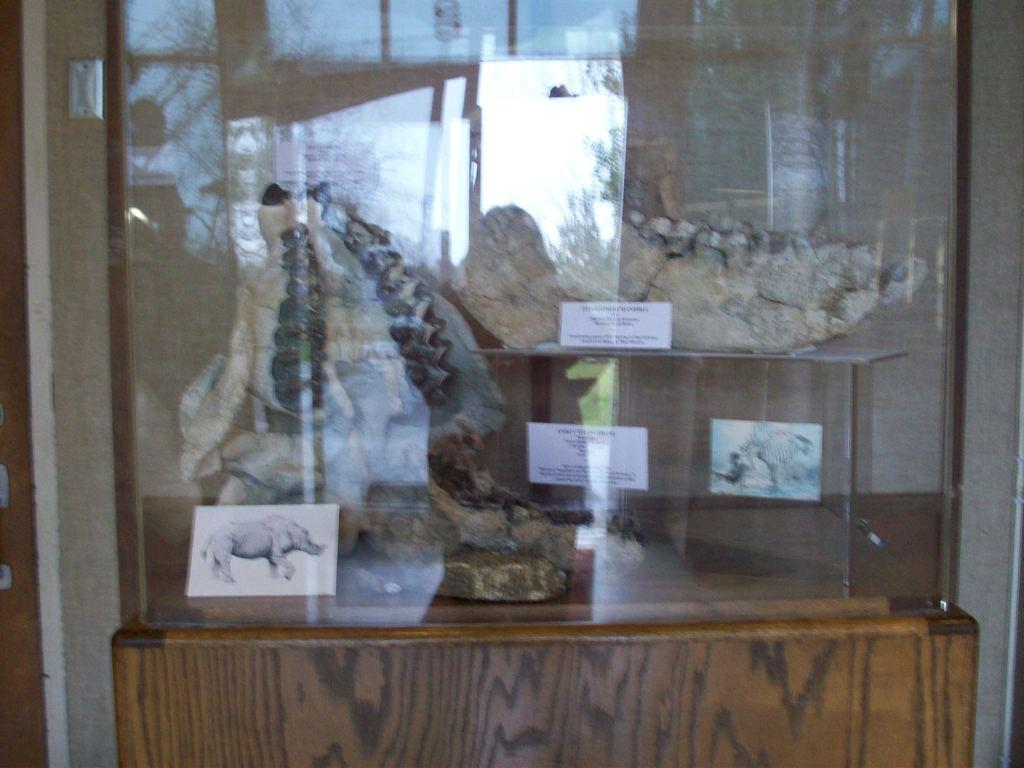What is the main subject in the foreground of the image? There is a skeleton of an animal in the foreground of the image. What else can be seen on the glass surface in the foreground? There are posters on the glass surface in the foreground. What type of surface is the glass surface resting on? The glass surface is on a wooden surface. What is visible in the background of the image? There is a wall in the background of the image. How does the basin help to copy the animal's cry in the image? There is no basin or animal cry present in the image. 